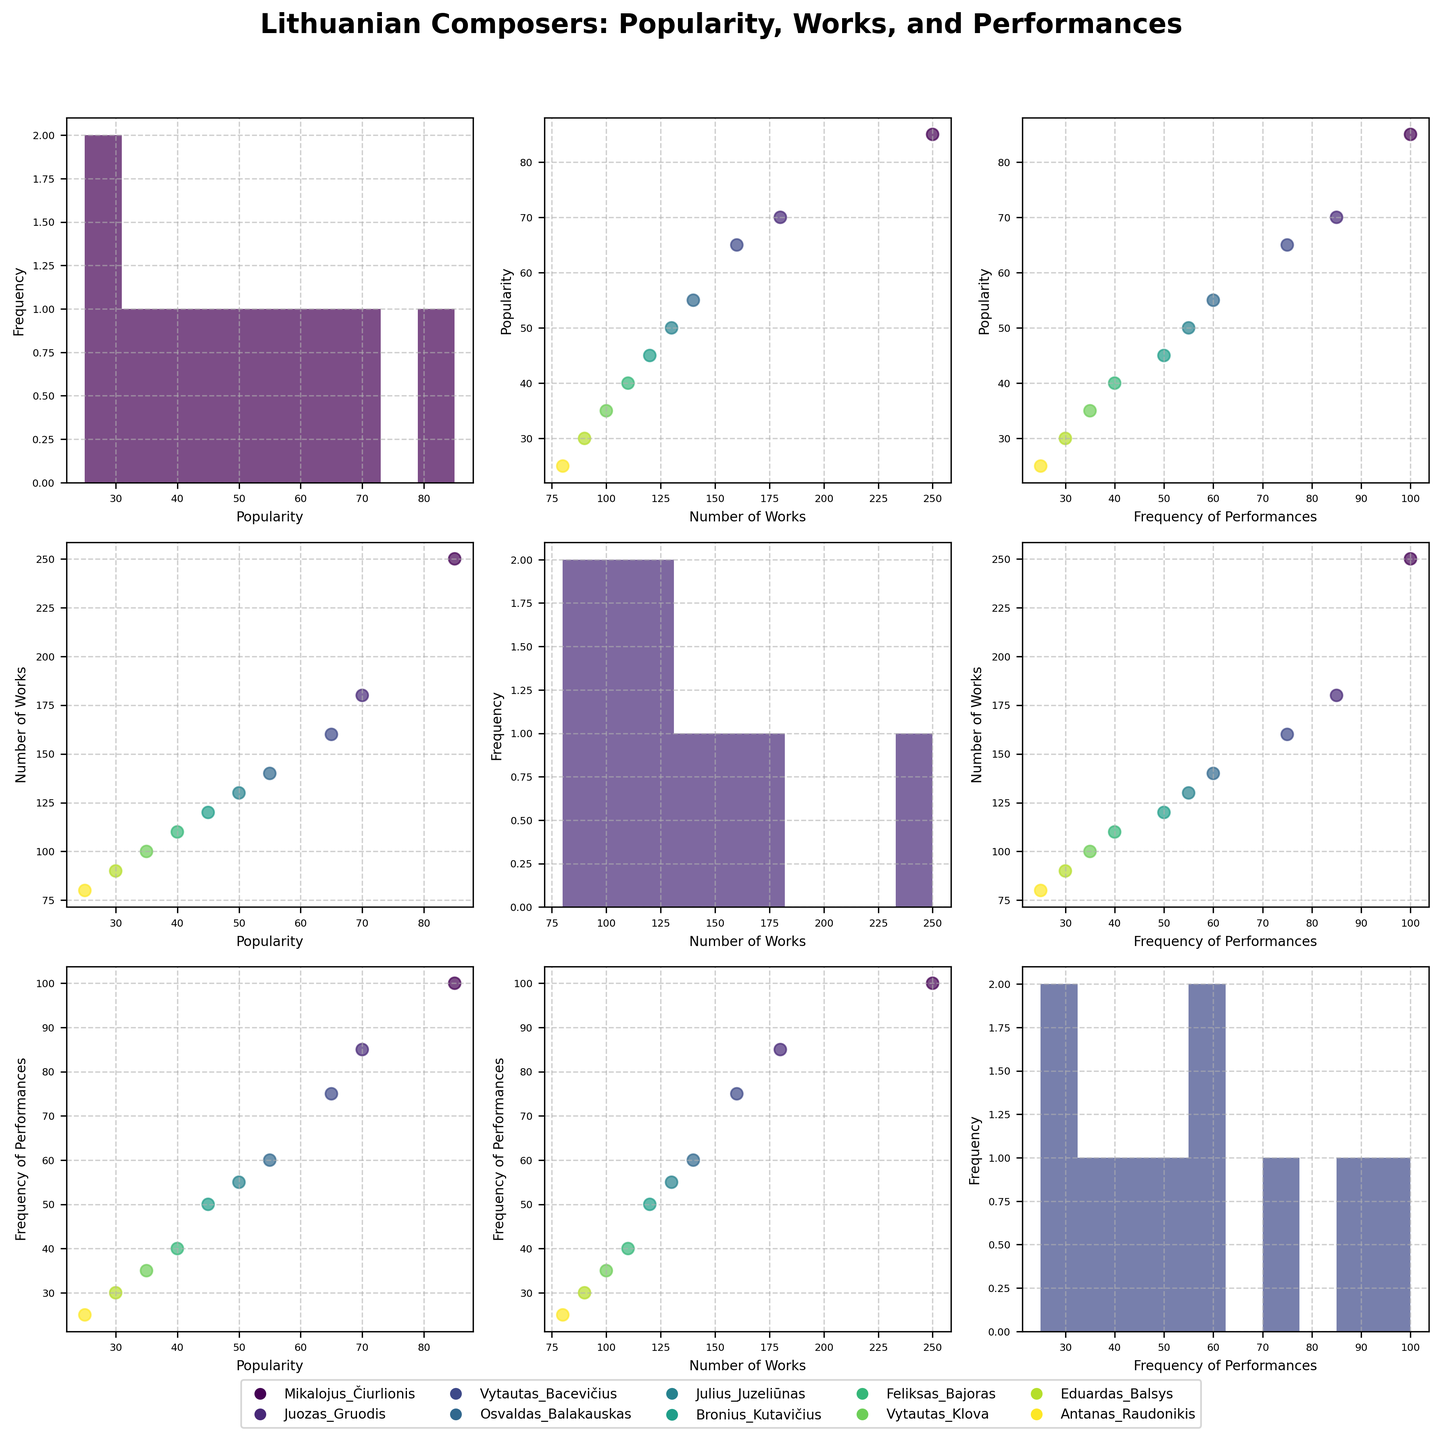Which composer has the highest popularity? According to the scatter plot, Mikalojus Čiurlionis has the highest popularity value of 85, as illustrated by the position along the vertical 'Popularity' axis in the SPLOM.
Answer: Mikalojus Čiurlionis What is the range of the frequency of performances? Observing the SPLOM histogram for 'Frequency of Performances', it ranges from approximately 25 to 100. The x-axis clearly indicates the lower and upper bounds of the frequency distribution.
Answer: 25 to 100 How does Julius Juzeliūnas's number of works compare to Vytautas Bacevičius's? By checking the scatter points in the SPLOM, Julius Juzeliūnas has around 130 works while Vytautas Bacevičius has about 160. Thus, Vytautas Bacevičius has 30 more works than Julius Juzeliūnas.
Answer: Vytautas Bacevičius has more Which composer has the lowest frequency of performances? Looking at the scatter plot matrix, the data point representing Antanas Raudonikis is furthest to the left on the 'Frequency of Performances' axis, indicating he has the lowest frequency value of 25.
Answer: Antanas Raudonikis What is the relationship between popularity and the number of works composed? By examining the scatter plots between 'Popularity' and 'Number of Works', there is a general positive trend visible, suggesting that composers with more works tend to have higher popularity, though the correlation is not perfectly linear.
Answer: Positive trend Is there a clear correlation between the number of works composed and frequency of performances? Observing the scatter plots, there appears to be a positive correlation between 'Number of Works' and 'Frequency of Performances', as composers with more works generally seem to have higher performance frequencies.
Answer: Yes, positive correlation What is the average popularity of the composers? Calculate the average by adding all popularity values (85 + 70 + 65 + 55 + 50 + 45 + 40 + 35 + 30 + 25) and then dividing by the number of composers (10): (500 / 10).
Answer: 50 How does the popularity histogram compare to the number of works histogram? The histograms for 'Popularity' and 'Number of Works' both show a right-skewed distribution, indicating more composers are towards the lower end in both aspects but still spread across a wide range.
Answer: Both are right-skewed What can you infer about Mikalojus Čiurlionis based on the SPLOM? Mikalojus Čiurlionis is located at the upper end of all three metrics: highest popularity, highest number of works, and highest frequency of performances, indicating he is the most prominent among the composers.
Answer: Most prominent Does Osvaldas Balakauskas have more performances than Feliksas Bajoras? By examining the scatter plots involving 'Frequency of Performances', Osvaldas Balakauskas has a performance frequency of 60, while Feliksas Bajoras has 40.
Answer: Yes, more performances 